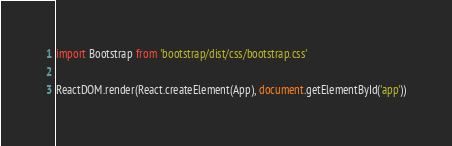Convert code to text. <code><loc_0><loc_0><loc_500><loc_500><_JavaScript_>import Bootstrap from 'bootstrap/dist/css/bootstrap.css'

ReactDOM.render(React.createElement(App), document.getElementById('app'))</code> 